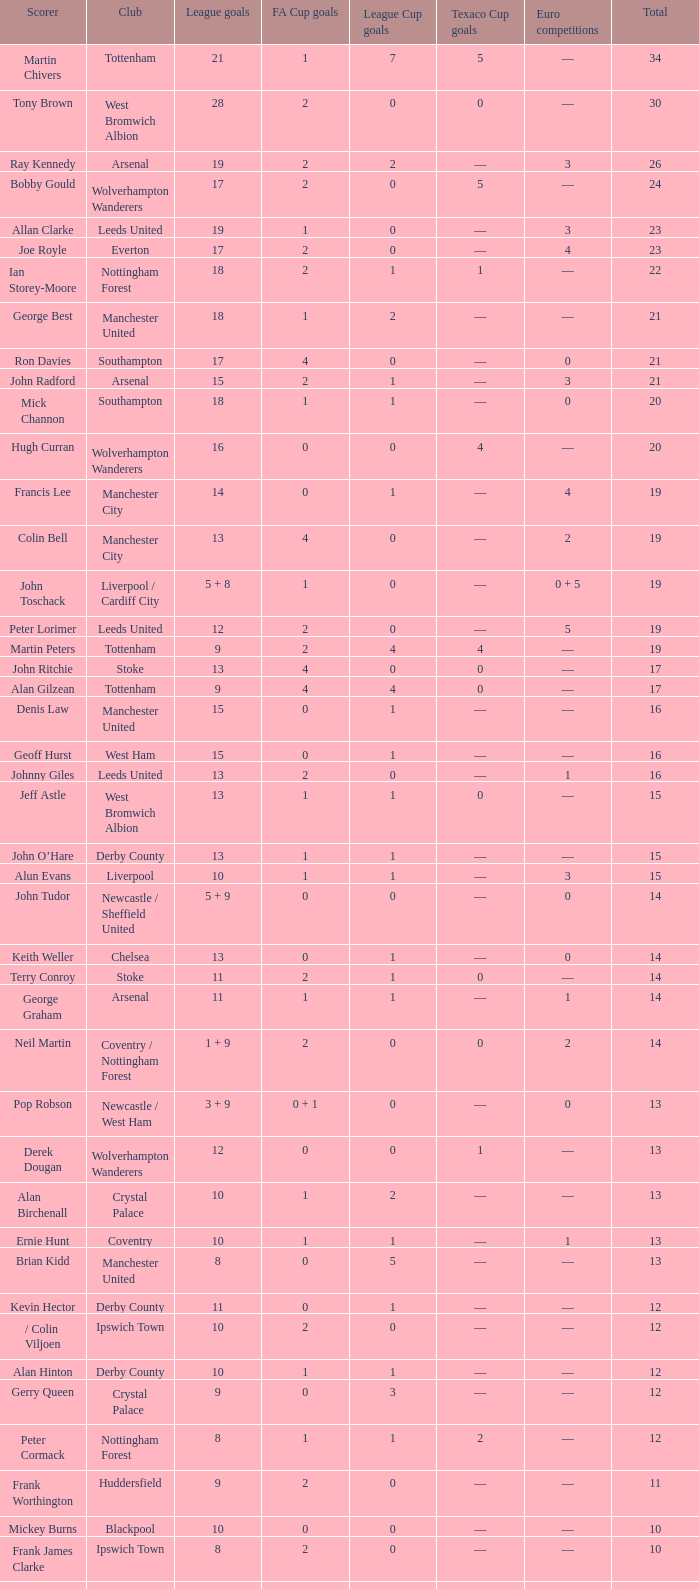What is the lowest League Cup Goals, when Scorer is Denis Law? 1.0. 